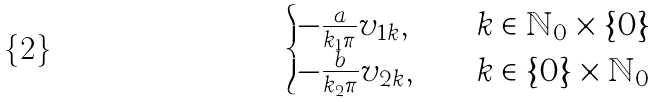Convert formula to latex. <formula><loc_0><loc_0><loc_500><loc_500>\begin{cases} - \frac { a } { k _ { 1 } \pi } v _ { 1 k } , \quad & k \in \mathbb { N } _ { 0 } \times \{ 0 \} \\ - \frac { b } { k _ { 2 } \pi } v _ { 2 k } , \quad & k \in \{ 0 \} \times \mathbb { N } _ { 0 } \end{cases}</formula> 